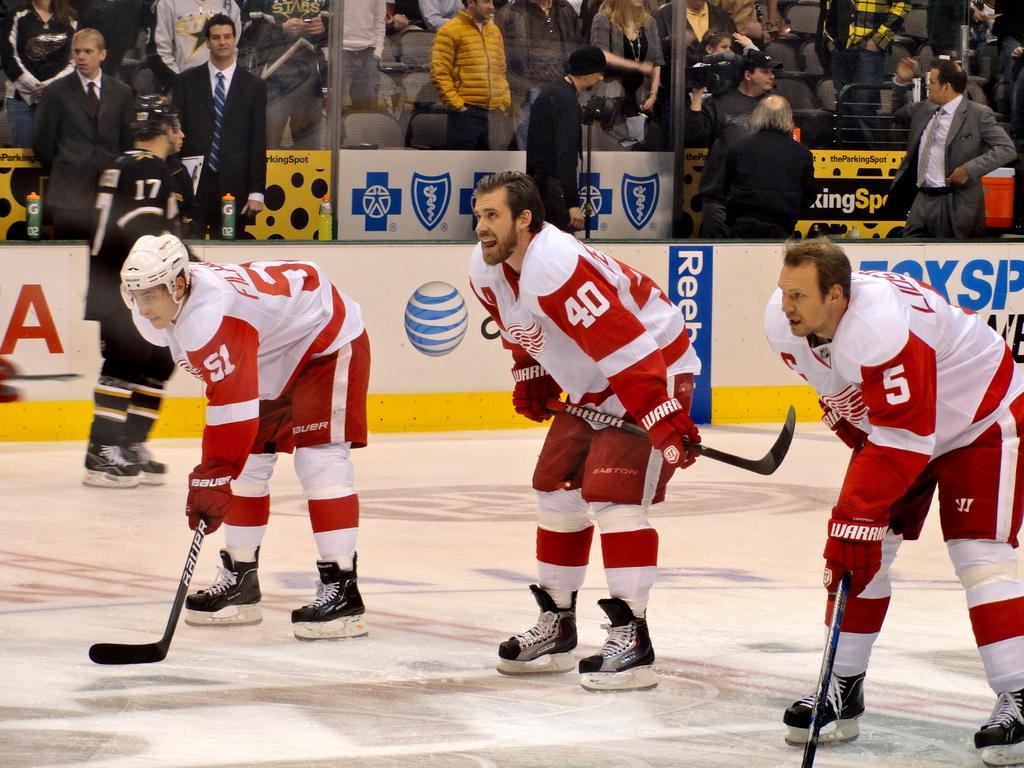How many players are in the image? There are three players in the image. What colors are the players wearing? The players are wearing white and red color dress. What sport are the players engaged in? The players are playing ice hockey. Can you describe the people watching the players? There is an audience in the image, and they are watching the players. What type of riddle can be seen on the ice during the ice hockey game? There is no riddle present on the ice during the ice hockey game; the players are focused on playing the sport. How many pizzas are being served to the audience in the image? There is no mention of pizzas in the image; the focus is on the ice hockey game and the audience watching it. 